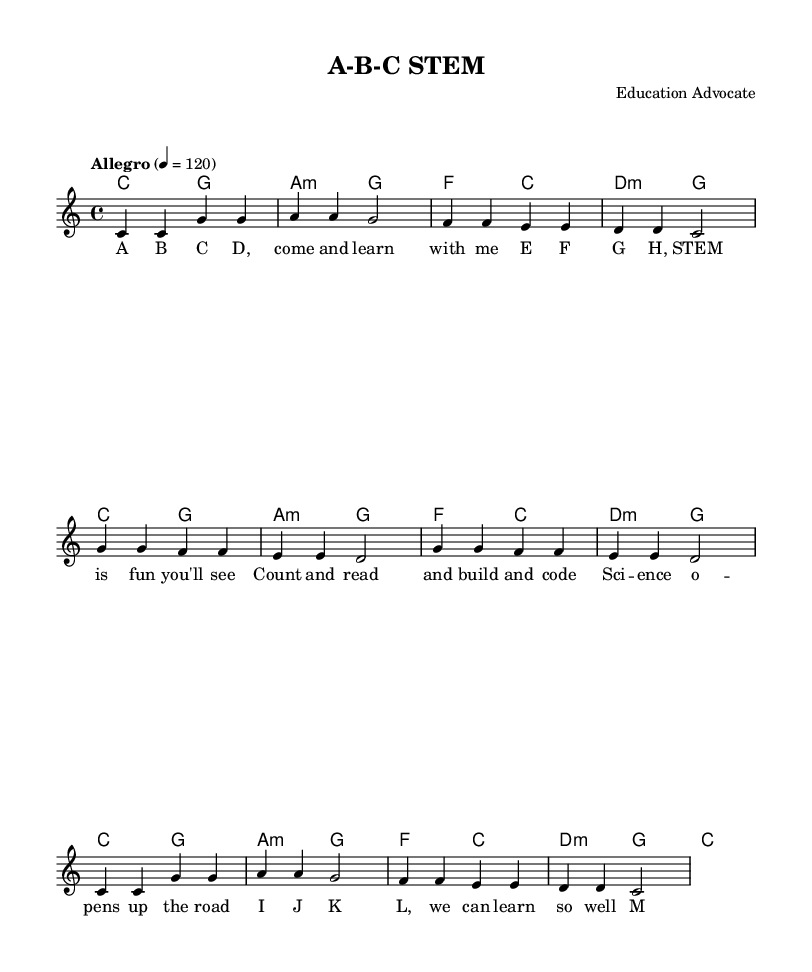What is the key signature of this music? The key signature is C major, which is indicated by the absence of any sharps or flats at the beginning of the staff.
Answer: C major What is the time signature of this music? The time signature is 4/4, which means there are four beats in a measure, and the quarter note receives one beat. This is clearly marked at the beginning of the music.
Answer: 4/4 What tempo marking is indicated at the beginning of the piece? The tempo marking is "Allegro" with a beat set at 120. This shows the piece should be played briskly.
Answer: Allegro 4 = 120 How many measures are in the melody section? The melody section consists of eight measures, as indicated by the grouping of notes and rests in the written music.
Answer: Eight measures What lyrics correspond to the first measure? The lyrics for the first measure are "A B C D, come and learn with me." This can be identified by aligning the melody notes with the lyrics beneath them.
Answer: A B C D, come and learn with me Which section of the lyrics emphasizes STEM learning? The section of the lyrics that emphasizes STEM learning is the phrase "STEM is fun you'll see," which highlights the educational theme within the song.
Answer: STEM is fun you'll see 